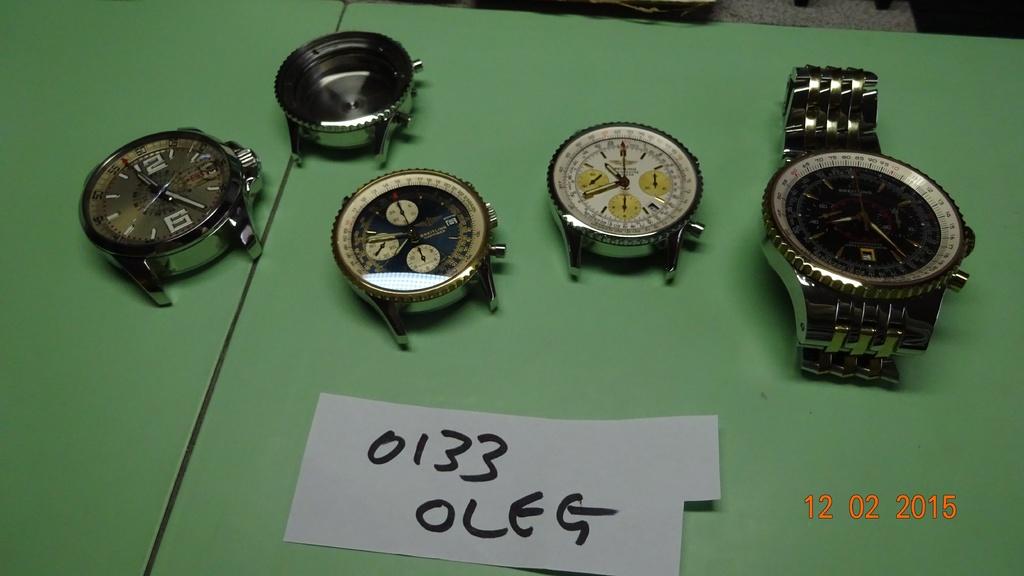Is oleg a brand name for watches?
Your answer should be very brief. Yes. 